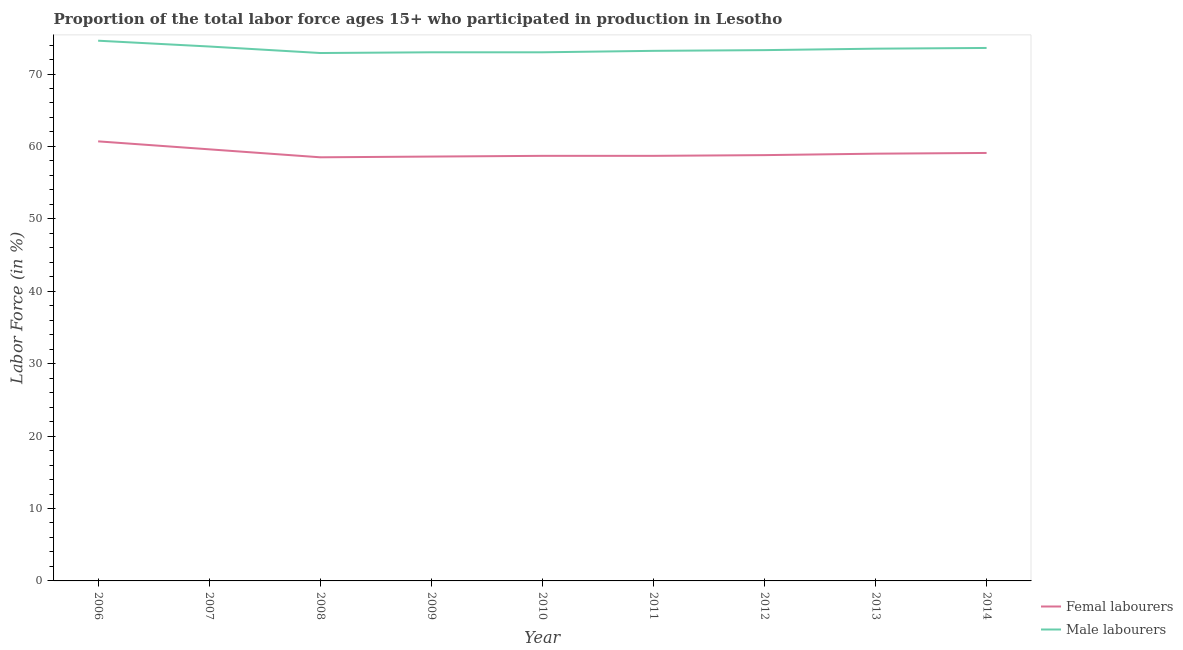How many different coloured lines are there?
Your response must be concise. 2. What is the percentage of male labour force in 2007?
Provide a short and direct response. 73.8. Across all years, what is the maximum percentage of male labour force?
Provide a short and direct response. 74.6. Across all years, what is the minimum percentage of male labour force?
Offer a terse response. 72.9. In which year was the percentage of male labour force minimum?
Offer a very short reply. 2008. What is the total percentage of female labor force in the graph?
Give a very brief answer. 531.7. What is the difference between the percentage of female labor force in 2006 and that in 2009?
Keep it short and to the point. 2.1. What is the difference between the percentage of female labor force in 2006 and the percentage of male labour force in 2008?
Keep it short and to the point. -12.2. What is the average percentage of male labour force per year?
Your response must be concise. 73.43. In the year 2007, what is the difference between the percentage of male labour force and percentage of female labor force?
Provide a short and direct response. 14.2. In how many years, is the percentage of male labour force greater than 28 %?
Provide a short and direct response. 9. What is the ratio of the percentage of male labour force in 2010 to that in 2014?
Your answer should be compact. 0.99. Is the percentage of female labor force in 2010 less than that in 2011?
Ensure brevity in your answer.  No. What is the difference between the highest and the second highest percentage of female labor force?
Provide a succinct answer. 1.1. What is the difference between the highest and the lowest percentage of female labor force?
Your answer should be compact. 2.2. In how many years, is the percentage of male labour force greater than the average percentage of male labour force taken over all years?
Keep it short and to the point. 4. How many years are there in the graph?
Provide a short and direct response. 9. What is the difference between two consecutive major ticks on the Y-axis?
Ensure brevity in your answer.  10. Does the graph contain any zero values?
Your answer should be compact. No. Where does the legend appear in the graph?
Make the answer very short. Bottom right. How many legend labels are there?
Keep it short and to the point. 2. How are the legend labels stacked?
Your answer should be compact. Vertical. What is the title of the graph?
Keep it short and to the point. Proportion of the total labor force ages 15+ who participated in production in Lesotho. What is the label or title of the Y-axis?
Provide a succinct answer. Labor Force (in %). What is the Labor Force (in %) of Femal labourers in 2006?
Provide a succinct answer. 60.7. What is the Labor Force (in %) of Male labourers in 2006?
Provide a succinct answer. 74.6. What is the Labor Force (in %) of Femal labourers in 2007?
Provide a succinct answer. 59.6. What is the Labor Force (in %) in Male labourers in 2007?
Give a very brief answer. 73.8. What is the Labor Force (in %) of Femal labourers in 2008?
Your answer should be compact. 58.5. What is the Labor Force (in %) of Male labourers in 2008?
Offer a very short reply. 72.9. What is the Labor Force (in %) in Femal labourers in 2009?
Your answer should be very brief. 58.6. What is the Labor Force (in %) in Femal labourers in 2010?
Offer a terse response. 58.7. What is the Labor Force (in %) of Femal labourers in 2011?
Provide a short and direct response. 58.7. What is the Labor Force (in %) in Male labourers in 2011?
Ensure brevity in your answer.  73.2. What is the Labor Force (in %) in Femal labourers in 2012?
Your answer should be compact. 58.8. What is the Labor Force (in %) of Male labourers in 2012?
Your response must be concise. 73.3. What is the Labor Force (in %) of Femal labourers in 2013?
Offer a very short reply. 59. What is the Labor Force (in %) in Male labourers in 2013?
Your answer should be very brief. 73.5. What is the Labor Force (in %) of Femal labourers in 2014?
Offer a terse response. 59.1. What is the Labor Force (in %) in Male labourers in 2014?
Your answer should be very brief. 73.6. Across all years, what is the maximum Labor Force (in %) in Femal labourers?
Offer a very short reply. 60.7. Across all years, what is the maximum Labor Force (in %) in Male labourers?
Your response must be concise. 74.6. Across all years, what is the minimum Labor Force (in %) of Femal labourers?
Keep it short and to the point. 58.5. Across all years, what is the minimum Labor Force (in %) of Male labourers?
Give a very brief answer. 72.9. What is the total Labor Force (in %) of Femal labourers in the graph?
Keep it short and to the point. 531.7. What is the total Labor Force (in %) in Male labourers in the graph?
Provide a short and direct response. 660.9. What is the difference between the Labor Force (in %) of Femal labourers in 2006 and that in 2007?
Keep it short and to the point. 1.1. What is the difference between the Labor Force (in %) of Femal labourers in 2006 and that in 2008?
Provide a short and direct response. 2.2. What is the difference between the Labor Force (in %) in Femal labourers in 2006 and that in 2009?
Offer a very short reply. 2.1. What is the difference between the Labor Force (in %) in Male labourers in 2006 and that in 2009?
Offer a terse response. 1.6. What is the difference between the Labor Force (in %) in Male labourers in 2006 and that in 2011?
Make the answer very short. 1.4. What is the difference between the Labor Force (in %) of Male labourers in 2006 and that in 2012?
Make the answer very short. 1.3. What is the difference between the Labor Force (in %) of Femal labourers in 2006 and that in 2013?
Make the answer very short. 1.7. What is the difference between the Labor Force (in %) in Male labourers in 2006 and that in 2013?
Your response must be concise. 1.1. What is the difference between the Labor Force (in %) in Femal labourers in 2006 and that in 2014?
Keep it short and to the point. 1.6. What is the difference between the Labor Force (in %) in Femal labourers in 2007 and that in 2009?
Provide a succinct answer. 1. What is the difference between the Labor Force (in %) in Femal labourers in 2007 and that in 2012?
Offer a very short reply. 0.8. What is the difference between the Labor Force (in %) in Male labourers in 2007 and that in 2012?
Ensure brevity in your answer.  0.5. What is the difference between the Labor Force (in %) of Femal labourers in 2007 and that in 2013?
Offer a terse response. 0.6. What is the difference between the Labor Force (in %) in Male labourers in 2008 and that in 2009?
Your answer should be very brief. -0.1. What is the difference between the Labor Force (in %) of Male labourers in 2008 and that in 2010?
Your answer should be compact. -0.1. What is the difference between the Labor Force (in %) in Male labourers in 2008 and that in 2012?
Make the answer very short. -0.4. What is the difference between the Labor Force (in %) of Femal labourers in 2008 and that in 2013?
Your answer should be very brief. -0.5. What is the difference between the Labor Force (in %) in Male labourers in 2008 and that in 2013?
Ensure brevity in your answer.  -0.6. What is the difference between the Labor Force (in %) of Femal labourers in 2008 and that in 2014?
Offer a very short reply. -0.6. What is the difference between the Labor Force (in %) in Male labourers in 2008 and that in 2014?
Make the answer very short. -0.7. What is the difference between the Labor Force (in %) of Male labourers in 2009 and that in 2010?
Give a very brief answer. 0. What is the difference between the Labor Force (in %) in Male labourers in 2009 and that in 2011?
Your response must be concise. -0.2. What is the difference between the Labor Force (in %) in Femal labourers in 2009 and that in 2012?
Your answer should be compact. -0.2. What is the difference between the Labor Force (in %) of Femal labourers in 2009 and that in 2013?
Provide a short and direct response. -0.4. What is the difference between the Labor Force (in %) in Male labourers in 2009 and that in 2013?
Ensure brevity in your answer.  -0.5. What is the difference between the Labor Force (in %) in Male labourers in 2009 and that in 2014?
Provide a succinct answer. -0.6. What is the difference between the Labor Force (in %) in Femal labourers in 2010 and that in 2012?
Provide a succinct answer. -0.1. What is the difference between the Labor Force (in %) of Male labourers in 2010 and that in 2012?
Your answer should be compact. -0.3. What is the difference between the Labor Force (in %) in Femal labourers in 2010 and that in 2013?
Make the answer very short. -0.3. What is the difference between the Labor Force (in %) of Male labourers in 2010 and that in 2013?
Your answer should be compact. -0.5. What is the difference between the Labor Force (in %) of Male labourers in 2010 and that in 2014?
Give a very brief answer. -0.6. What is the difference between the Labor Force (in %) of Femal labourers in 2011 and that in 2012?
Your answer should be very brief. -0.1. What is the difference between the Labor Force (in %) of Male labourers in 2011 and that in 2012?
Provide a succinct answer. -0.1. What is the difference between the Labor Force (in %) in Femal labourers in 2011 and that in 2014?
Offer a terse response. -0.4. What is the difference between the Labor Force (in %) of Femal labourers in 2012 and that in 2013?
Provide a short and direct response. -0.2. What is the difference between the Labor Force (in %) in Male labourers in 2012 and that in 2013?
Offer a very short reply. -0.2. What is the difference between the Labor Force (in %) in Male labourers in 2012 and that in 2014?
Provide a short and direct response. -0.3. What is the difference between the Labor Force (in %) in Femal labourers in 2006 and the Labor Force (in %) in Male labourers in 2013?
Your answer should be very brief. -12.8. What is the difference between the Labor Force (in %) in Femal labourers in 2007 and the Labor Force (in %) in Male labourers in 2008?
Offer a very short reply. -13.3. What is the difference between the Labor Force (in %) in Femal labourers in 2007 and the Labor Force (in %) in Male labourers in 2010?
Give a very brief answer. -13.4. What is the difference between the Labor Force (in %) in Femal labourers in 2007 and the Labor Force (in %) in Male labourers in 2011?
Keep it short and to the point. -13.6. What is the difference between the Labor Force (in %) of Femal labourers in 2007 and the Labor Force (in %) of Male labourers in 2012?
Your answer should be compact. -13.7. What is the difference between the Labor Force (in %) in Femal labourers in 2007 and the Labor Force (in %) in Male labourers in 2013?
Keep it short and to the point. -13.9. What is the difference between the Labor Force (in %) in Femal labourers in 2008 and the Labor Force (in %) in Male labourers in 2010?
Your answer should be very brief. -14.5. What is the difference between the Labor Force (in %) of Femal labourers in 2008 and the Labor Force (in %) of Male labourers in 2011?
Make the answer very short. -14.7. What is the difference between the Labor Force (in %) of Femal labourers in 2008 and the Labor Force (in %) of Male labourers in 2012?
Make the answer very short. -14.8. What is the difference between the Labor Force (in %) in Femal labourers in 2008 and the Labor Force (in %) in Male labourers in 2014?
Provide a short and direct response. -15.1. What is the difference between the Labor Force (in %) of Femal labourers in 2009 and the Labor Force (in %) of Male labourers in 2010?
Provide a short and direct response. -14.4. What is the difference between the Labor Force (in %) in Femal labourers in 2009 and the Labor Force (in %) in Male labourers in 2011?
Make the answer very short. -14.6. What is the difference between the Labor Force (in %) of Femal labourers in 2009 and the Labor Force (in %) of Male labourers in 2012?
Offer a very short reply. -14.7. What is the difference between the Labor Force (in %) of Femal labourers in 2009 and the Labor Force (in %) of Male labourers in 2013?
Offer a very short reply. -14.9. What is the difference between the Labor Force (in %) of Femal labourers in 2010 and the Labor Force (in %) of Male labourers in 2012?
Your answer should be compact. -14.6. What is the difference between the Labor Force (in %) in Femal labourers in 2010 and the Labor Force (in %) in Male labourers in 2013?
Give a very brief answer. -14.8. What is the difference between the Labor Force (in %) in Femal labourers in 2010 and the Labor Force (in %) in Male labourers in 2014?
Offer a terse response. -14.9. What is the difference between the Labor Force (in %) in Femal labourers in 2011 and the Labor Force (in %) in Male labourers in 2012?
Make the answer very short. -14.6. What is the difference between the Labor Force (in %) in Femal labourers in 2011 and the Labor Force (in %) in Male labourers in 2013?
Your answer should be very brief. -14.8. What is the difference between the Labor Force (in %) of Femal labourers in 2011 and the Labor Force (in %) of Male labourers in 2014?
Provide a succinct answer. -14.9. What is the difference between the Labor Force (in %) in Femal labourers in 2012 and the Labor Force (in %) in Male labourers in 2013?
Offer a terse response. -14.7. What is the difference between the Labor Force (in %) of Femal labourers in 2012 and the Labor Force (in %) of Male labourers in 2014?
Offer a terse response. -14.8. What is the difference between the Labor Force (in %) of Femal labourers in 2013 and the Labor Force (in %) of Male labourers in 2014?
Keep it short and to the point. -14.6. What is the average Labor Force (in %) in Femal labourers per year?
Ensure brevity in your answer.  59.08. What is the average Labor Force (in %) in Male labourers per year?
Offer a very short reply. 73.43. In the year 2006, what is the difference between the Labor Force (in %) of Femal labourers and Labor Force (in %) of Male labourers?
Your response must be concise. -13.9. In the year 2007, what is the difference between the Labor Force (in %) of Femal labourers and Labor Force (in %) of Male labourers?
Your response must be concise. -14.2. In the year 2008, what is the difference between the Labor Force (in %) of Femal labourers and Labor Force (in %) of Male labourers?
Your answer should be very brief. -14.4. In the year 2009, what is the difference between the Labor Force (in %) of Femal labourers and Labor Force (in %) of Male labourers?
Offer a very short reply. -14.4. In the year 2010, what is the difference between the Labor Force (in %) of Femal labourers and Labor Force (in %) of Male labourers?
Your answer should be compact. -14.3. In the year 2012, what is the difference between the Labor Force (in %) in Femal labourers and Labor Force (in %) in Male labourers?
Ensure brevity in your answer.  -14.5. In the year 2013, what is the difference between the Labor Force (in %) in Femal labourers and Labor Force (in %) in Male labourers?
Your answer should be very brief. -14.5. In the year 2014, what is the difference between the Labor Force (in %) in Femal labourers and Labor Force (in %) in Male labourers?
Give a very brief answer. -14.5. What is the ratio of the Labor Force (in %) in Femal labourers in 2006 to that in 2007?
Give a very brief answer. 1.02. What is the ratio of the Labor Force (in %) in Male labourers in 2006 to that in 2007?
Offer a terse response. 1.01. What is the ratio of the Labor Force (in %) of Femal labourers in 2006 to that in 2008?
Give a very brief answer. 1.04. What is the ratio of the Labor Force (in %) of Male labourers in 2006 to that in 2008?
Make the answer very short. 1.02. What is the ratio of the Labor Force (in %) of Femal labourers in 2006 to that in 2009?
Ensure brevity in your answer.  1.04. What is the ratio of the Labor Force (in %) in Male labourers in 2006 to that in 2009?
Make the answer very short. 1.02. What is the ratio of the Labor Force (in %) in Femal labourers in 2006 to that in 2010?
Provide a succinct answer. 1.03. What is the ratio of the Labor Force (in %) in Male labourers in 2006 to that in 2010?
Offer a terse response. 1.02. What is the ratio of the Labor Force (in %) in Femal labourers in 2006 to that in 2011?
Provide a succinct answer. 1.03. What is the ratio of the Labor Force (in %) of Male labourers in 2006 to that in 2011?
Provide a succinct answer. 1.02. What is the ratio of the Labor Force (in %) in Femal labourers in 2006 to that in 2012?
Ensure brevity in your answer.  1.03. What is the ratio of the Labor Force (in %) of Male labourers in 2006 to that in 2012?
Offer a terse response. 1.02. What is the ratio of the Labor Force (in %) of Femal labourers in 2006 to that in 2013?
Provide a succinct answer. 1.03. What is the ratio of the Labor Force (in %) of Male labourers in 2006 to that in 2013?
Your answer should be compact. 1.01. What is the ratio of the Labor Force (in %) of Femal labourers in 2006 to that in 2014?
Offer a terse response. 1.03. What is the ratio of the Labor Force (in %) of Male labourers in 2006 to that in 2014?
Give a very brief answer. 1.01. What is the ratio of the Labor Force (in %) in Femal labourers in 2007 to that in 2008?
Provide a short and direct response. 1.02. What is the ratio of the Labor Force (in %) in Male labourers in 2007 to that in 2008?
Give a very brief answer. 1.01. What is the ratio of the Labor Force (in %) of Femal labourers in 2007 to that in 2009?
Provide a short and direct response. 1.02. What is the ratio of the Labor Force (in %) of Male labourers in 2007 to that in 2009?
Make the answer very short. 1.01. What is the ratio of the Labor Force (in %) of Femal labourers in 2007 to that in 2010?
Offer a very short reply. 1.02. What is the ratio of the Labor Force (in %) in Male labourers in 2007 to that in 2010?
Offer a terse response. 1.01. What is the ratio of the Labor Force (in %) of Femal labourers in 2007 to that in 2011?
Your answer should be compact. 1.02. What is the ratio of the Labor Force (in %) in Male labourers in 2007 to that in 2011?
Your answer should be very brief. 1.01. What is the ratio of the Labor Force (in %) in Femal labourers in 2007 to that in 2012?
Your response must be concise. 1.01. What is the ratio of the Labor Force (in %) in Male labourers in 2007 to that in 2012?
Give a very brief answer. 1.01. What is the ratio of the Labor Force (in %) in Femal labourers in 2007 to that in 2013?
Offer a very short reply. 1.01. What is the ratio of the Labor Force (in %) of Femal labourers in 2007 to that in 2014?
Provide a short and direct response. 1.01. What is the ratio of the Labor Force (in %) in Male labourers in 2007 to that in 2014?
Offer a terse response. 1. What is the ratio of the Labor Force (in %) of Male labourers in 2008 to that in 2009?
Ensure brevity in your answer.  1. What is the ratio of the Labor Force (in %) of Femal labourers in 2008 to that in 2010?
Your answer should be very brief. 1. What is the ratio of the Labor Force (in %) of Male labourers in 2008 to that in 2010?
Keep it short and to the point. 1. What is the ratio of the Labor Force (in %) in Femal labourers in 2008 to that in 2011?
Ensure brevity in your answer.  1. What is the ratio of the Labor Force (in %) in Male labourers in 2008 to that in 2013?
Make the answer very short. 0.99. What is the ratio of the Labor Force (in %) of Male labourers in 2008 to that in 2014?
Provide a short and direct response. 0.99. What is the ratio of the Labor Force (in %) of Femal labourers in 2009 to that in 2010?
Offer a terse response. 1. What is the ratio of the Labor Force (in %) in Male labourers in 2009 to that in 2010?
Offer a very short reply. 1. What is the ratio of the Labor Force (in %) of Femal labourers in 2009 to that in 2011?
Ensure brevity in your answer.  1. What is the ratio of the Labor Force (in %) in Male labourers in 2009 to that in 2012?
Your response must be concise. 1. What is the ratio of the Labor Force (in %) in Femal labourers in 2009 to that in 2013?
Make the answer very short. 0.99. What is the ratio of the Labor Force (in %) of Male labourers in 2009 to that in 2013?
Give a very brief answer. 0.99. What is the ratio of the Labor Force (in %) of Femal labourers in 2009 to that in 2014?
Give a very brief answer. 0.99. What is the ratio of the Labor Force (in %) of Male labourers in 2009 to that in 2014?
Offer a terse response. 0.99. What is the ratio of the Labor Force (in %) of Male labourers in 2010 to that in 2012?
Offer a very short reply. 1. What is the ratio of the Labor Force (in %) in Male labourers in 2010 to that in 2013?
Your answer should be compact. 0.99. What is the ratio of the Labor Force (in %) in Male labourers in 2010 to that in 2014?
Offer a very short reply. 0.99. What is the ratio of the Labor Force (in %) of Femal labourers in 2011 to that in 2013?
Offer a very short reply. 0.99. What is the ratio of the Labor Force (in %) of Male labourers in 2011 to that in 2014?
Offer a very short reply. 0.99. What is the ratio of the Labor Force (in %) of Male labourers in 2012 to that in 2013?
Give a very brief answer. 1. What is the ratio of the Labor Force (in %) of Male labourers in 2012 to that in 2014?
Ensure brevity in your answer.  1. What is the difference between the highest and the second highest Labor Force (in %) of Femal labourers?
Give a very brief answer. 1.1. 